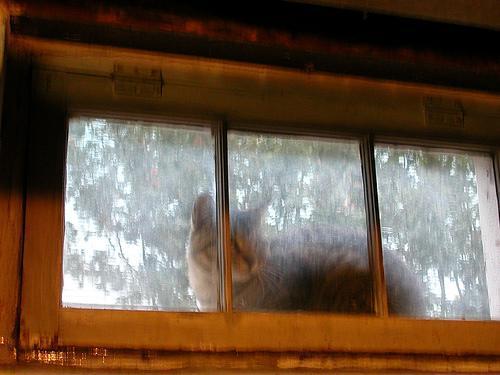How many cats are there?
Give a very brief answer. 1. How many window panes are there?
Give a very brief answer. 3. 